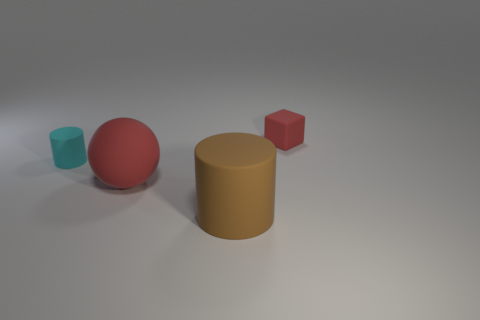What is the size of the thing in front of the large ball?
Offer a very short reply. Large. There is a tiny object that is behind the tiny matte cylinder; is it the same color as the big matte cylinder?
Give a very brief answer. No. What number of tiny cyan rubber things have the same shape as the large red thing?
Provide a succinct answer. 0. How many things are objects in front of the cyan rubber object or red matte objects in front of the small cyan cylinder?
Your answer should be compact. 2. What number of red objects are rubber cylinders or small things?
Make the answer very short. 1. Is the material of the tiny cyan thing the same as the tiny red block?
Give a very brief answer. Yes. How many other rubber balls have the same size as the matte ball?
Make the answer very short. 0. Is the number of red objects that are in front of the red sphere the same as the number of small purple metal cubes?
Offer a terse response. Yes. What number of things are both in front of the block and behind the big brown matte cylinder?
Offer a very short reply. 2. Is the shape of the small thing on the left side of the large cylinder the same as  the big brown thing?
Keep it short and to the point. Yes. 